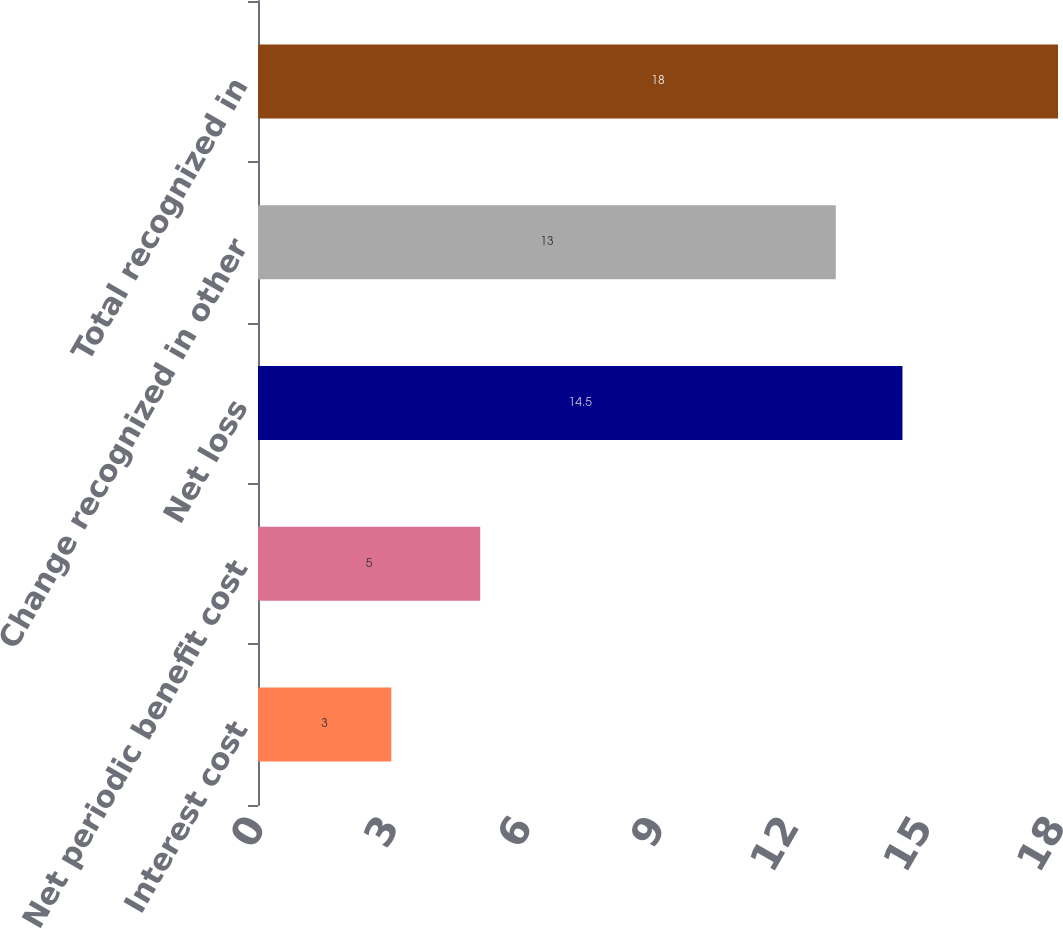Convert chart to OTSL. <chart><loc_0><loc_0><loc_500><loc_500><bar_chart><fcel>Interest cost<fcel>Net periodic benefit cost<fcel>Net loss<fcel>Change recognized in other<fcel>Total recognized in<nl><fcel>3<fcel>5<fcel>14.5<fcel>13<fcel>18<nl></chart> 